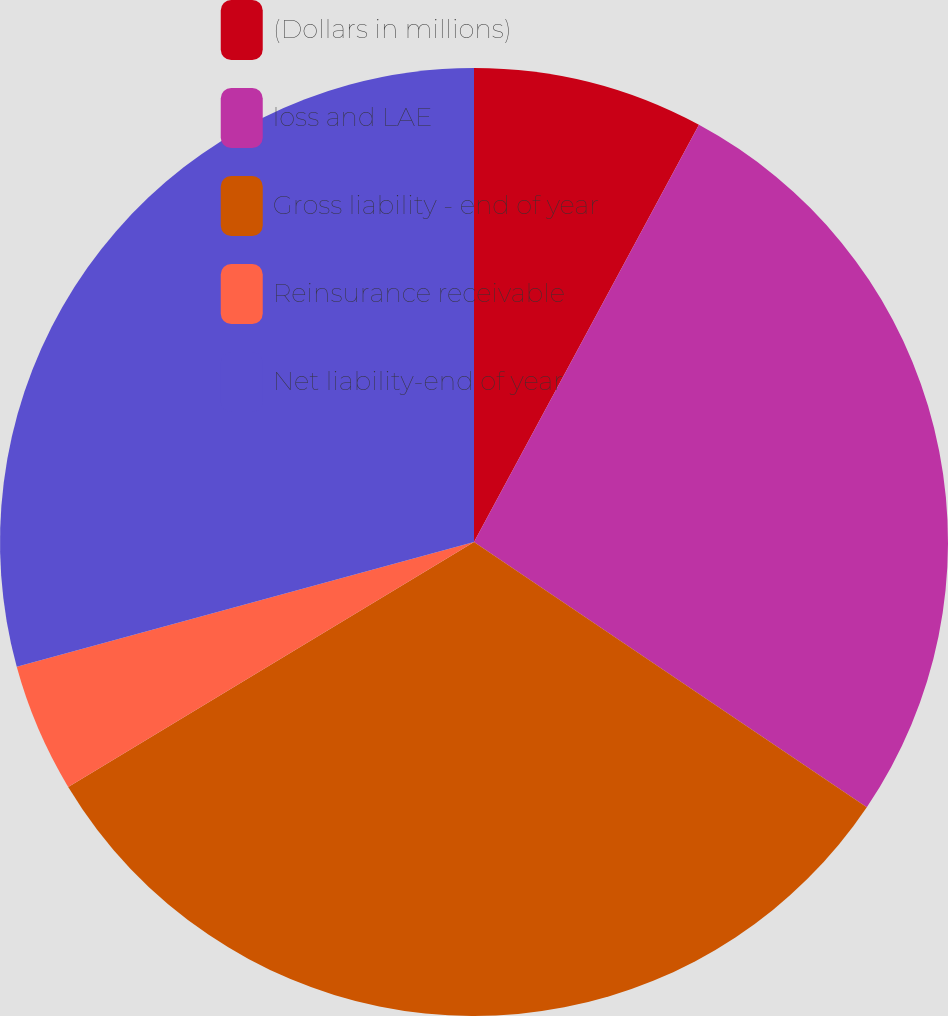Convert chart. <chart><loc_0><loc_0><loc_500><loc_500><pie_chart><fcel>(Dollars in millions)<fcel>loss and LAE<fcel>Gross liability - end of year<fcel>Reinsurance receivable<fcel>Net liability-end of year<nl><fcel>7.87%<fcel>26.58%<fcel>31.9%<fcel>4.4%<fcel>29.24%<nl></chart> 